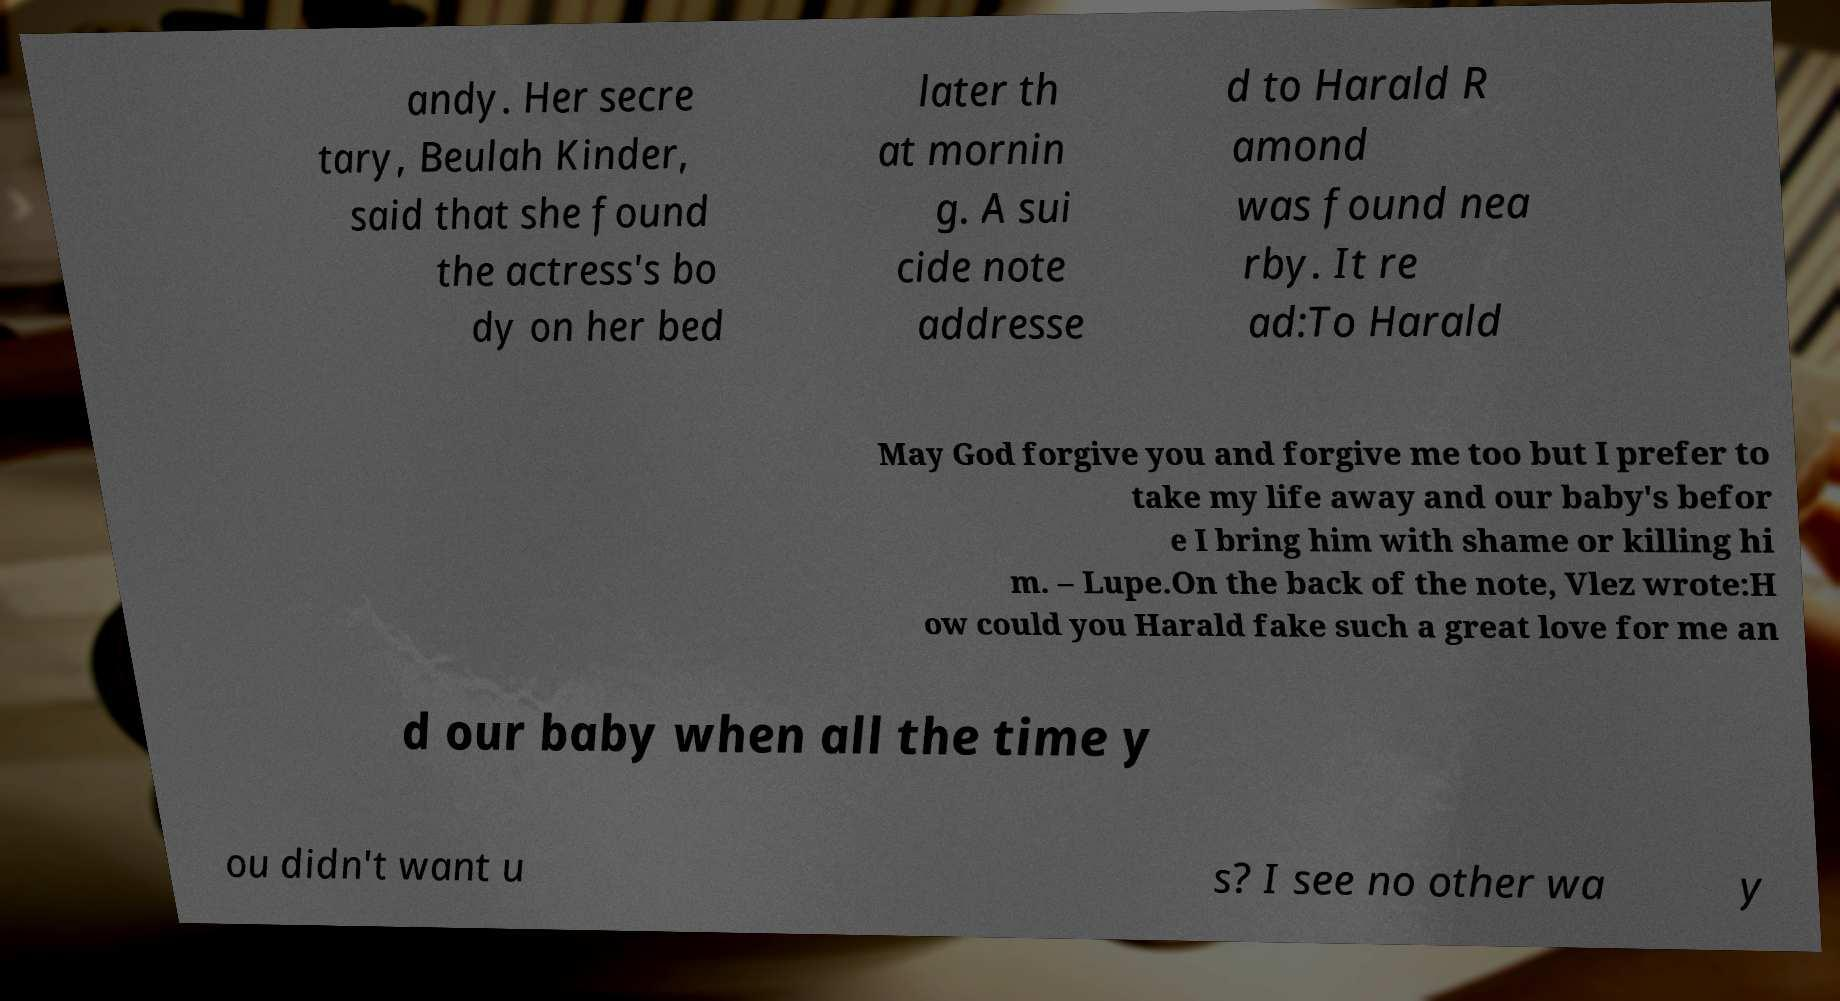For documentation purposes, I need the text within this image transcribed. Could you provide that? andy. Her secre tary, Beulah Kinder, said that she found the actress's bo dy on her bed later th at mornin g. A sui cide note addresse d to Harald R amond was found nea rby. It re ad:To Harald May God forgive you and forgive me too but I prefer to take my life away and our baby's befor e I bring him with shame or killing hi m. – Lupe.On the back of the note, Vlez wrote:H ow could you Harald fake such a great love for me an d our baby when all the time y ou didn't want u s? I see no other wa y 